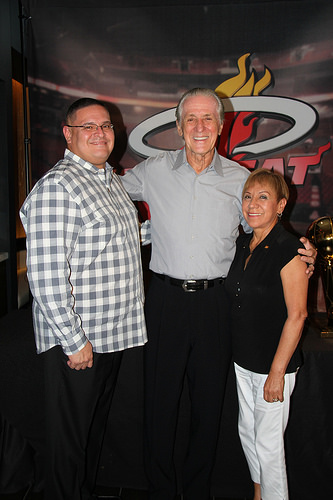<image>
Is there a aunty to the left of the uncle? Yes. From this viewpoint, the aunty is positioned to the left side relative to the uncle. Where is the man in relation to the woman? Is it next to the woman? Yes. The man is positioned adjacent to the woman, located nearby in the same general area. Where is the woman in relation to the man? Is it in front of the man? No. The woman is not in front of the man. The spatial positioning shows a different relationship between these objects. 